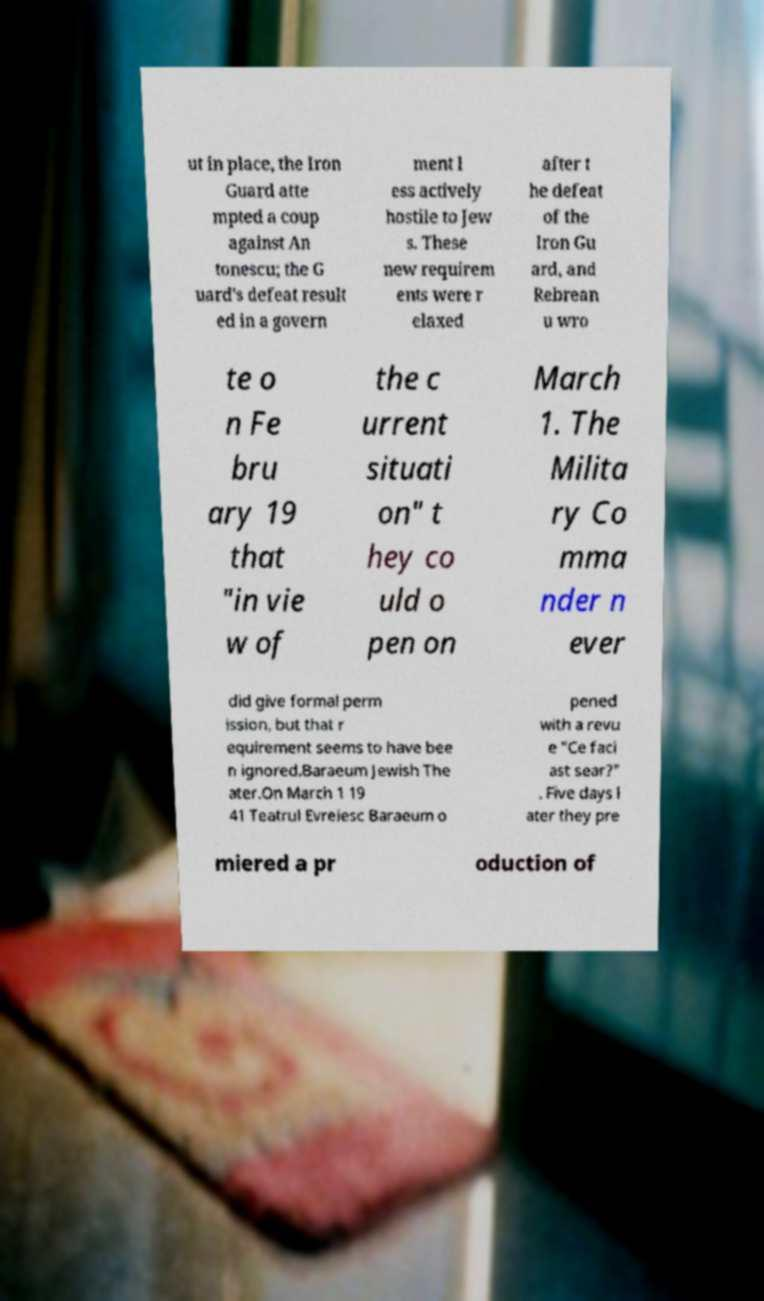For documentation purposes, I need the text within this image transcribed. Could you provide that? ut in place, the Iron Guard atte mpted a coup against An tonescu; the G uard's defeat result ed in a govern ment l ess actively hostile to Jew s. These new requirem ents were r elaxed after t he defeat of the Iron Gu ard, and Rebrean u wro te o n Fe bru ary 19 that "in vie w of the c urrent situati on" t hey co uld o pen on March 1. The Milita ry Co mma nder n ever did give formal perm ission, but that r equirement seems to have bee n ignored.Baraeum Jewish The ater.On March 1 19 41 Teatrul Evreiesc Baraeum o pened with a revu e "Ce faci ast sear?" . Five days l ater they pre miered a pr oduction of 